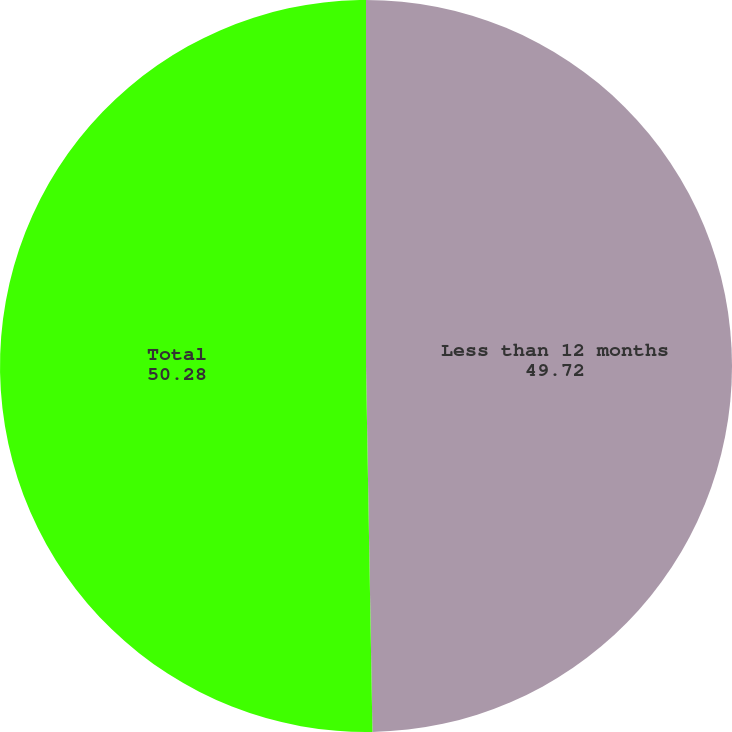Convert chart to OTSL. <chart><loc_0><loc_0><loc_500><loc_500><pie_chart><fcel>Less than 12 months<fcel>Total<nl><fcel>49.72%<fcel>50.28%<nl></chart> 